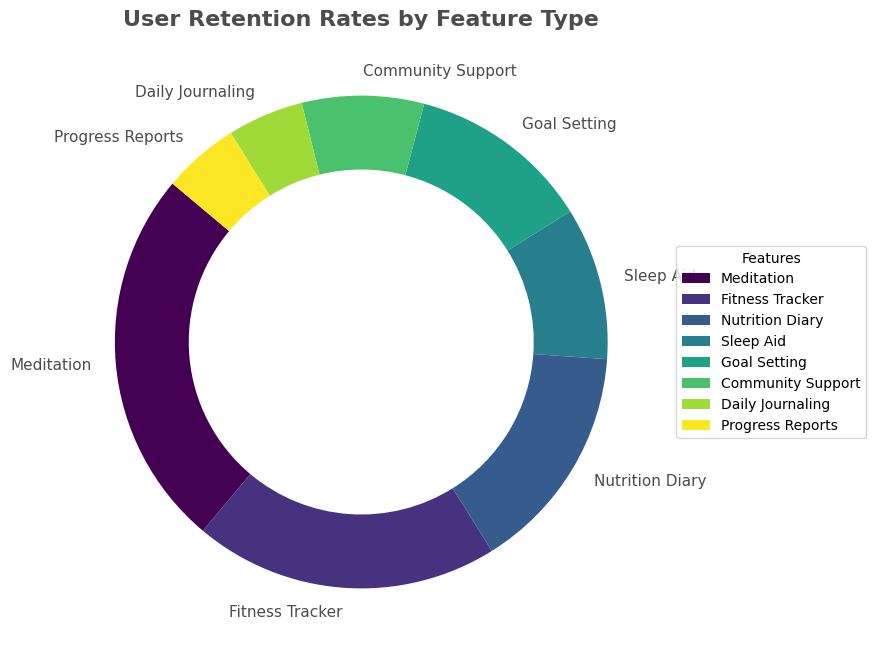What's the feature with the highest retention rate? The figure shows retention rates for different features. The largest segment is labeled as 'Meditation' with a retention rate of 25%, so it has the highest retention rate.
Answer: Meditation What's the combined retention rate of the Sleep Aid and Daily Journaling features? The Sleep Aid feature has a retention rate of 10%, and Daily Journaling has 5%. Adding these together gives 10% + 5% = 15%.
Answer: 15% Which feature has the lowest retention rate, and what's its percentage? Looking at the figure, the smallest segments are labeled 'Daily Journaling' and 'Progress Reports,' each with a retention rate of 5%.
Answer: Daily Journaling and Progress Reports, 5% What's the difference in retention rate between the feature with the highest rate and the one with the lowest rate? The highest retention rate is for Meditation at 25%, and the lowest is for Daily Journaling and Progress Reports at 5%. The difference is 25% - 5% = 20%.
Answer: 20% How does the retention rate for Fitness Tracker compare to that of Community Support? The retention rate for Fitness Tracker is 20%, while for Community Support it's 8%. Clearly, the Fitness Tracker's rate is higher than Community Support's.
Answer: Fitness Tracker's rate is higher What's the total retention rate of all features combined? Adding the percentages of all the features: 25% (Meditation) + 20% (Fitness Tracker) + 15% (Nutrition Diary) + 10% (Sleep Aid) + 12% (Goal Setting) + 8% (Community Support) + 5% (Daily Journaling) + 5% (Progress Reports) = 100%.
Answer: 100% Which feature is represented by the second-largest segment in the visual, and what is its retention rate? The second-largest segment corresponds to the Fitness Tracker feature, with a retention rate of 20%.
Answer: Fitness Tracker, 20% What's the retention rate for feature types that fall below 10%? From the visual, the features with retention rates below 10% are Community Support (8%), Daily Journaling (5%), and Progress Reports (5%).
Answer: Community Support (8%), Daily Journaling (5%), Progress Reports (5%) What color is used to represent the Nutrition Diary feature? The visual uses a color gradient, and the Nutrition Diary segment can be identified by its distinct color. It is the segment that’s third in size and is represented in a shade in the middle of the color gradient.
Answer: A shade in the middle of the color gradient What's the average retention rate for all feature types? To calculate the average, sum all the retention rates: 25% (Meditation) + 20% (Fitness Tracker) + 15% (Nutrition Diary) + 10% (Sleep Aid) + 12% (Goal Setting) + 8% (Community Support) + 5% (Daily Journaling) + 5% (Progress Reports) = 100%. There are 8 features, so the average retention rate is 100% / 8 = 12.5%.
Answer: 12.5% 